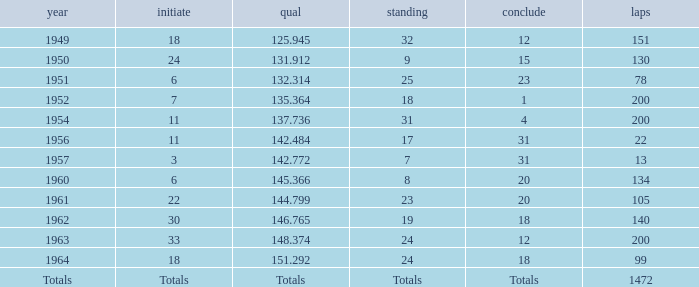Would you mind parsing the complete table? {'header': ['year', 'initiate', 'qual', 'standing', 'conclude', 'laps'], 'rows': [['1949', '18', '125.945', '32', '12', '151'], ['1950', '24', '131.912', '9', '15', '130'], ['1951', '6', '132.314', '25', '23', '78'], ['1952', '7', '135.364', '18', '1', '200'], ['1954', '11', '137.736', '31', '4', '200'], ['1956', '11', '142.484', '17', '31', '22'], ['1957', '3', '142.772', '7', '31', '13'], ['1960', '6', '145.366', '8', '20', '134'], ['1961', '22', '144.799', '23', '20', '105'], ['1962', '30', '146.765', '19', '18', '140'], ['1963', '33', '148.374', '24', '12', '200'], ['1964', '18', '151.292', '24', '18', '99'], ['Totals', 'Totals', 'Totals', 'Totals', 'Totals', '1472']]} Name the finish with Laps more than 200 Totals. 